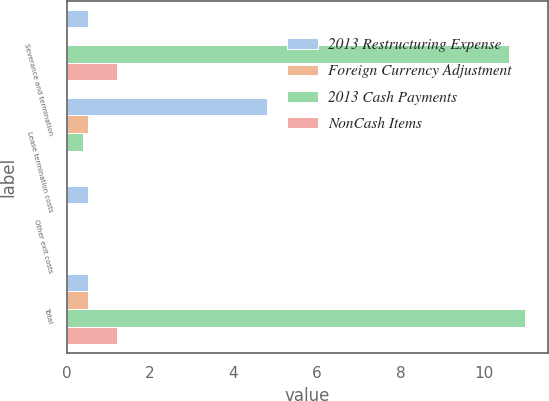<chart> <loc_0><loc_0><loc_500><loc_500><stacked_bar_chart><ecel><fcel>Severance and termination<fcel>Lease termination costs<fcel>Other exit costs<fcel>Total<nl><fcel>2013 Restructuring Expense<fcel>0.5<fcel>4.8<fcel>0.5<fcel>0.5<nl><fcel>Foreign Currency Adjustment<fcel>0<fcel>0.5<fcel>0<fcel>0.5<nl><fcel>2013 Cash Payments<fcel>10.6<fcel>0.4<fcel>0<fcel>11<nl><fcel>NonCash Items<fcel>1.2<fcel>0<fcel>0<fcel>1.2<nl></chart> 